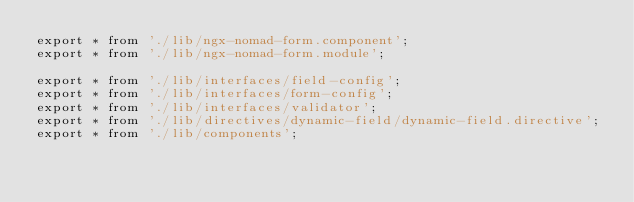<code> <loc_0><loc_0><loc_500><loc_500><_TypeScript_>export * from './lib/ngx-nomad-form.component';
export * from './lib/ngx-nomad-form.module';

export * from './lib/interfaces/field-config';
export * from './lib/interfaces/form-config';
export * from './lib/interfaces/validator';
export * from './lib/directives/dynamic-field/dynamic-field.directive';
export * from './lib/components';
</code> 